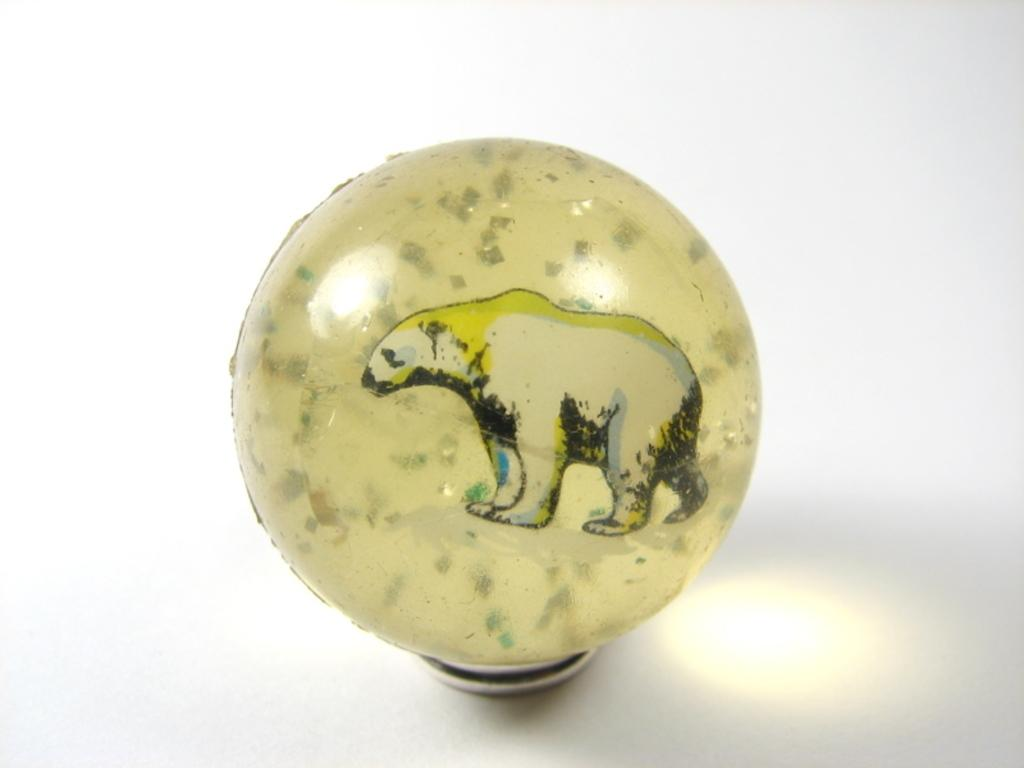What is the main object in the image? There is a ball-shaped object in the image. What is depicted on the ball-shaped object? The ball-shaped object has a painting of a bear on it. What color is the background of the image? The background of the image is white. How does the bear in the painting on the ball-shaped object react to the rain in the image? There is no rain present in the image, so the bear's reaction cannot be determined. 